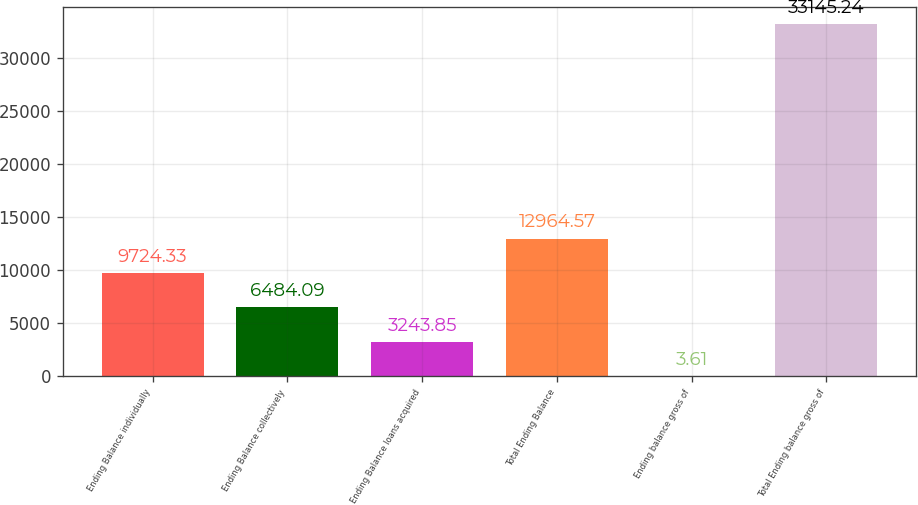Convert chart to OTSL. <chart><loc_0><loc_0><loc_500><loc_500><bar_chart><fcel>Ending Balance individually<fcel>Ending Balance collectively<fcel>Ending Balance loans acquired<fcel>Total Ending Balance<fcel>Ending balance gross of<fcel>Total Ending balance gross of<nl><fcel>9724.33<fcel>6484.09<fcel>3243.85<fcel>12964.6<fcel>3.61<fcel>33145.2<nl></chart> 